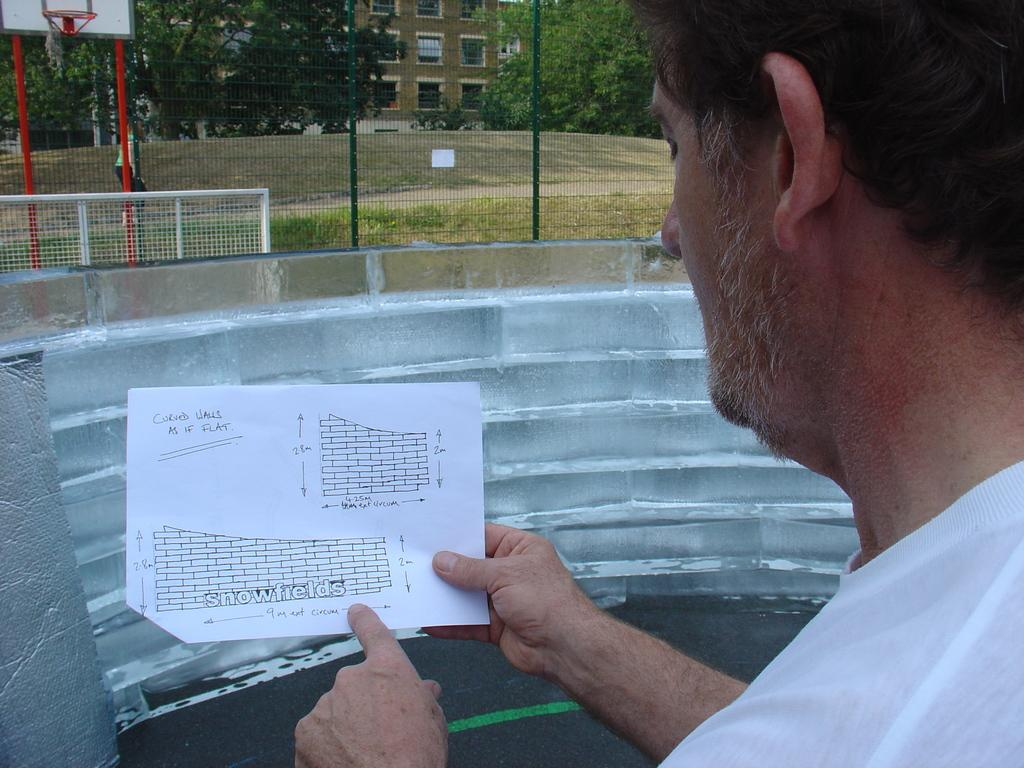What is the person in the image holding? The person is holding a paper with text. What can be seen in the background of the image? There is a building and trees in the background of the image. Is there any sports equipment visible in the image? Yes, there is a basketball net in the image. How is the person measuring the cord in the image? There is no cord present in the image, so it cannot be measured. 